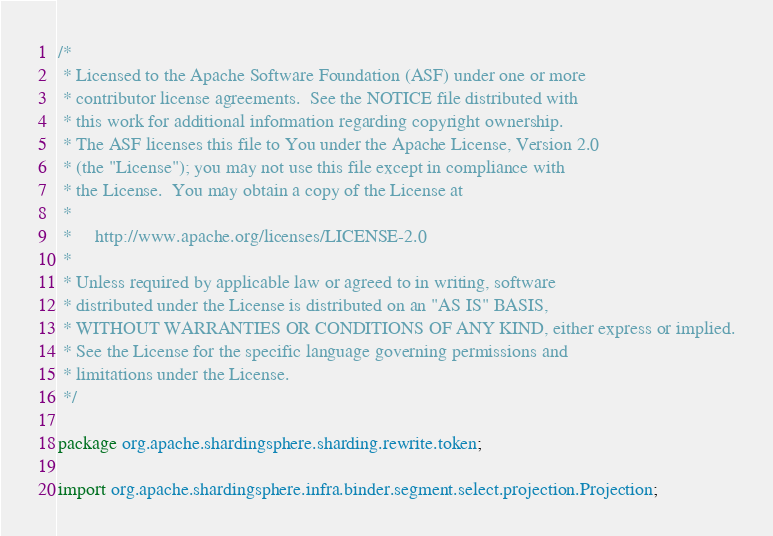Convert code to text. <code><loc_0><loc_0><loc_500><loc_500><_Java_>/*
 * Licensed to the Apache Software Foundation (ASF) under one or more
 * contributor license agreements.  See the NOTICE file distributed with
 * this work for additional information regarding copyright ownership.
 * The ASF licenses this file to You under the Apache License, Version 2.0
 * (the "License"); you may not use this file except in compliance with
 * the License.  You may obtain a copy of the License at
 *
 *     http://www.apache.org/licenses/LICENSE-2.0
 *
 * Unless required by applicable law or agreed to in writing, software
 * distributed under the License is distributed on an "AS IS" BASIS,
 * WITHOUT WARRANTIES OR CONDITIONS OF ANY KIND, either express or implied.
 * See the License for the specific language governing permissions and
 * limitations under the License.
 */

package org.apache.shardingsphere.sharding.rewrite.token;

import org.apache.shardingsphere.infra.binder.segment.select.projection.Projection;</code> 